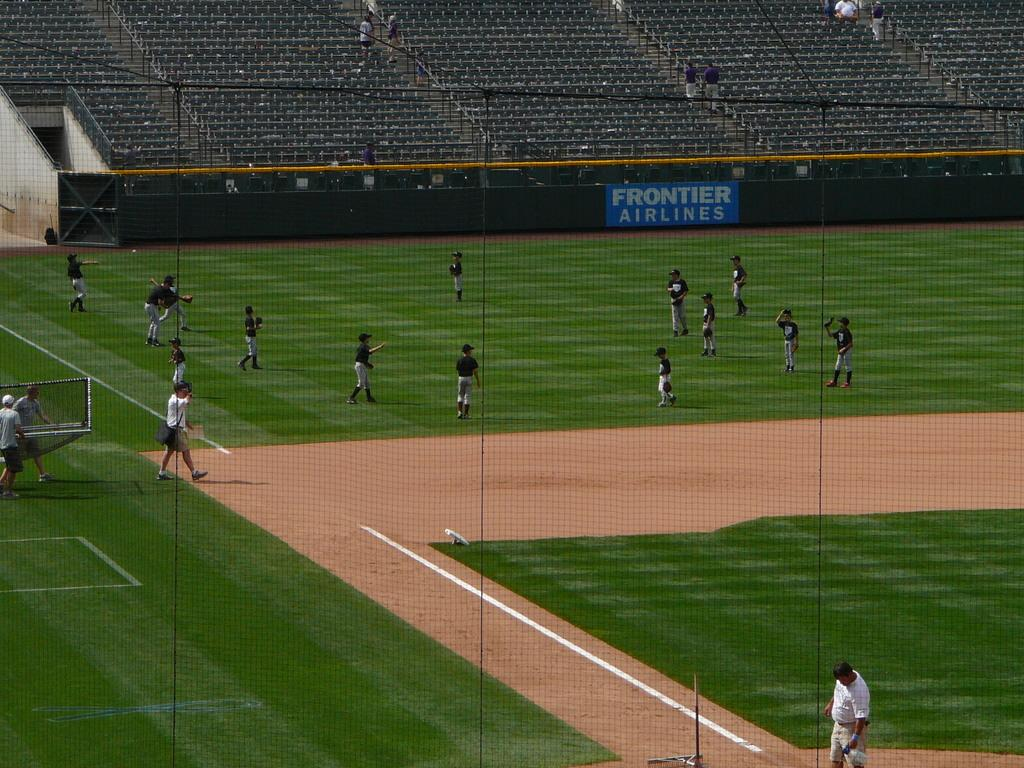<image>
Present a compact description of the photo's key features. a baseball wall that has Frontier Airlines on it 